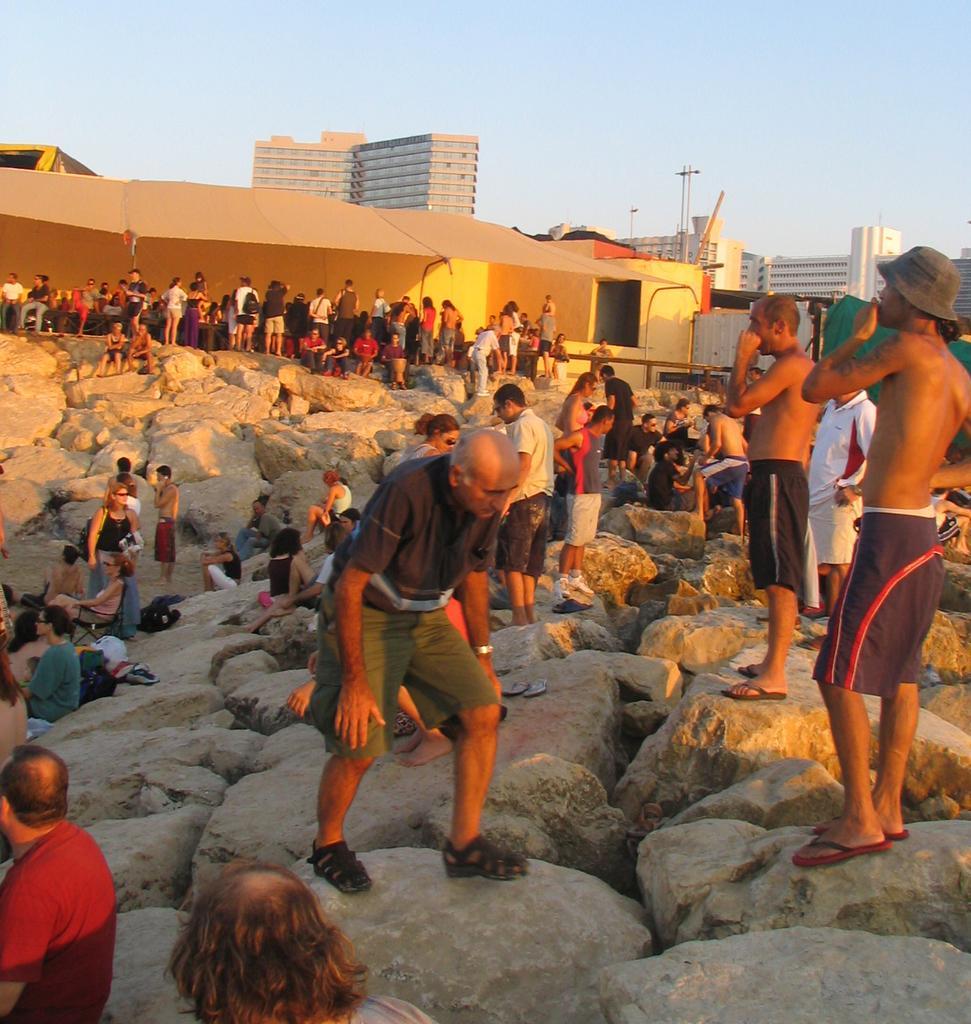Can you describe this image briefly? In this picture we can see a group of people standing on the stones and some people are sitting on the stones. Behind the people there are buildings, poles and sky. 